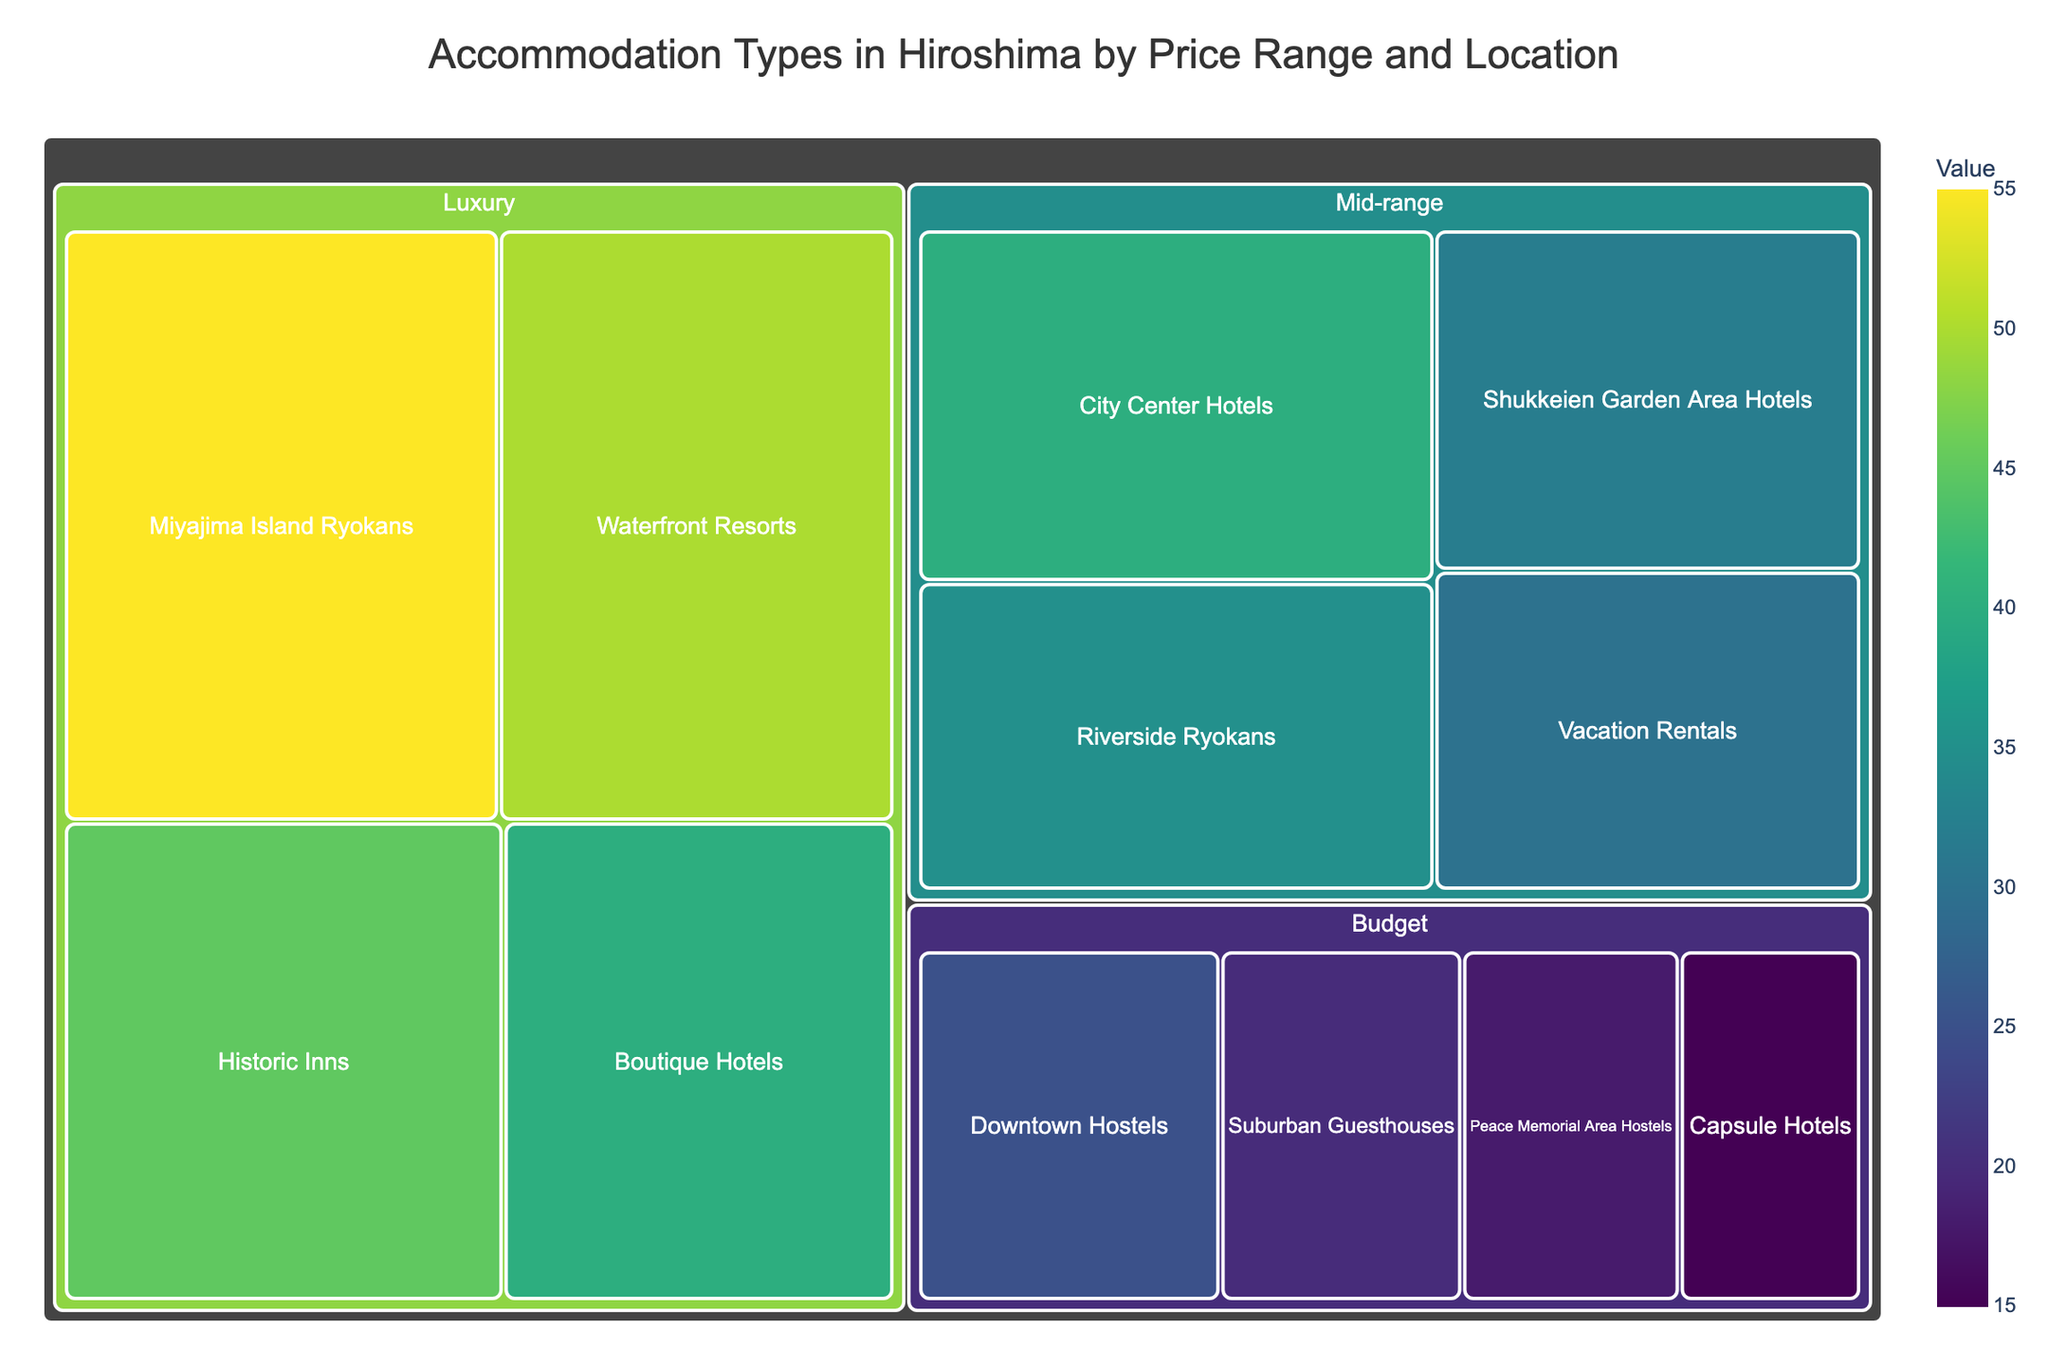What is the highest value accommodation type under the Luxury category? The treemap shows different accommodation types under the Luxury category, with numerical values representing each. The highest value is the one with 55.
Answer: Miyajima Island Ryokans Which category has the overall highest value total? First, find the total value for each category by summing the relevant subcategory values:
- Budget: 25 + 20 + 15 + 18 = 78
- Mid-range: 40 + 35 + 30 + 32 = 137
- Luxury: 50 + 45 + 40 + 55 = 190
The category with the highest total is the Luxury category.
Answer: Luxury How many subcategory types are there in the Mid-range category? The Mid-range category has multiple subcategories, and using the treemap, we can see that there are a total of four subcategories.
Answer: Four What is the sum of values of all Budget accommodations located outside the Downtown? Sum the values of Budget subcategories outside Downtown: Suburban Guesthouses (20), Capsule Hotels (15), and Peace Memorial Area Hostels (18):
20 + 15 + 18 = 53
Answer: 53 Compare the values of Downtown Hostels in the Budget category and City Center Hotels in the Mid-range category. Which one is higher? The value of Downtown Hostels in the Budget category is 25, and the value of City Center Hotels in the Mid-range category is 40. Clearly, 40 is greater than 25.
Answer: City Center Hotels Which subcategory in the Mid-range category has the smallest value? By examining the numerical values in the treemap, the smallest value in the Mid-range category is Vacation Rentals with a value of 30.
Answer: Vacation Rentals How does the value of Riverside Ryokans compare to Waterfront Resorts? The value of Riverside Ryokans is 35, while that of Waterfront Resorts is 50. Since 50 is greater than 35, Waterfront Resorts has a higher value.
Answer: Riverside Ryokans Considering all accommodation types, what is the most common price range category? Count the subcategories in each price range:
- Budget: 4
- Mid-range: 4
- Luxury: 4
They are all equal, each having four subcategories.
Answer: Equal What is the average value of the Boutique Hotels and Capsule Hotels subcategories combined? Add their values and divide by 2:
Boutique Hotels (40) + Capsule Hotels (15) = 55
55/2 = 27.5
Answer: 27.5 Which accommodation type in the Budget category has the smallest value? The treemap shows that the smallest value in the Budget category is Capsule Hotels with a value of 15.
Answer: Capsule Hotels 